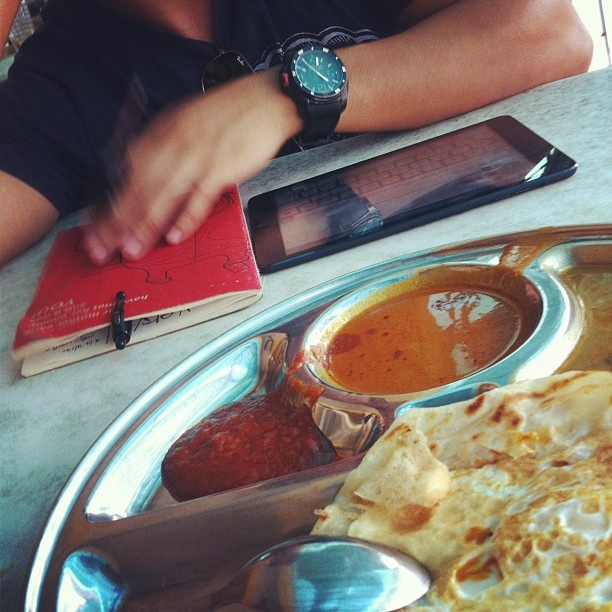Describe the objects in this image and their specific colors. I can see dining table in red, gray, darkgray, maroon, and tan tones, people in red, black, brown, tan, and maroon tones, cell phone in red, gray, and black tones, book in red, brown, maroon, and darkgray tones, and spoon in red, gray, teal, ivory, and black tones in this image. 